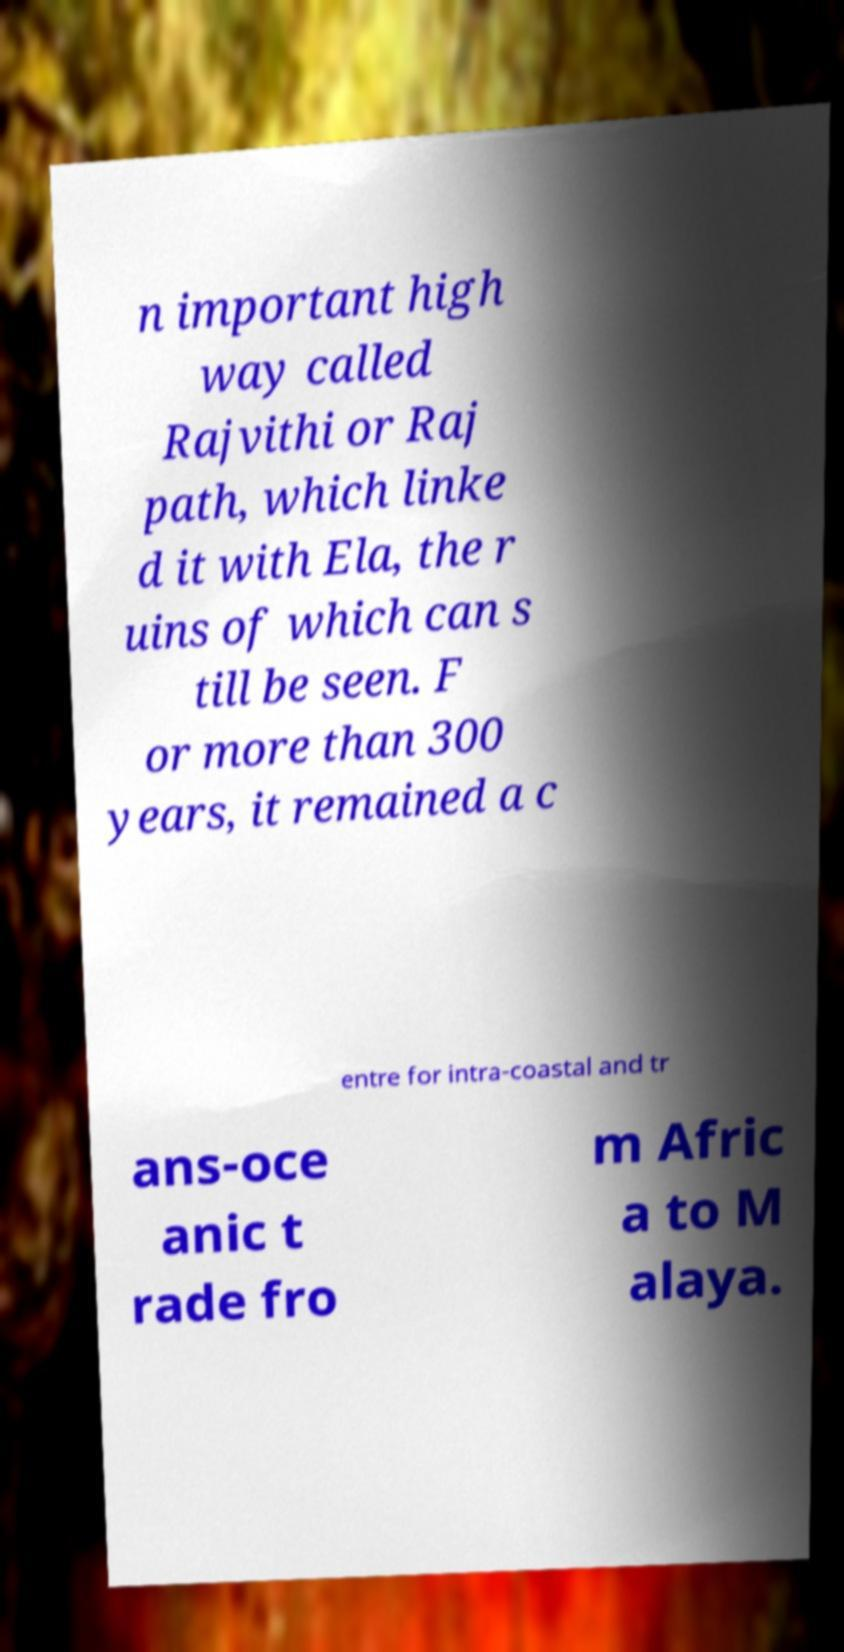Could you assist in decoding the text presented in this image and type it out clearly? n important high way called Rajvithi or Raj path, which linke d it with Ela, the r uins of which can s till be seen. F or more than 300 years, it remained a c entre for intra-coastal and tr ans-oce anic t rade fro m Afric a to M alaya. 